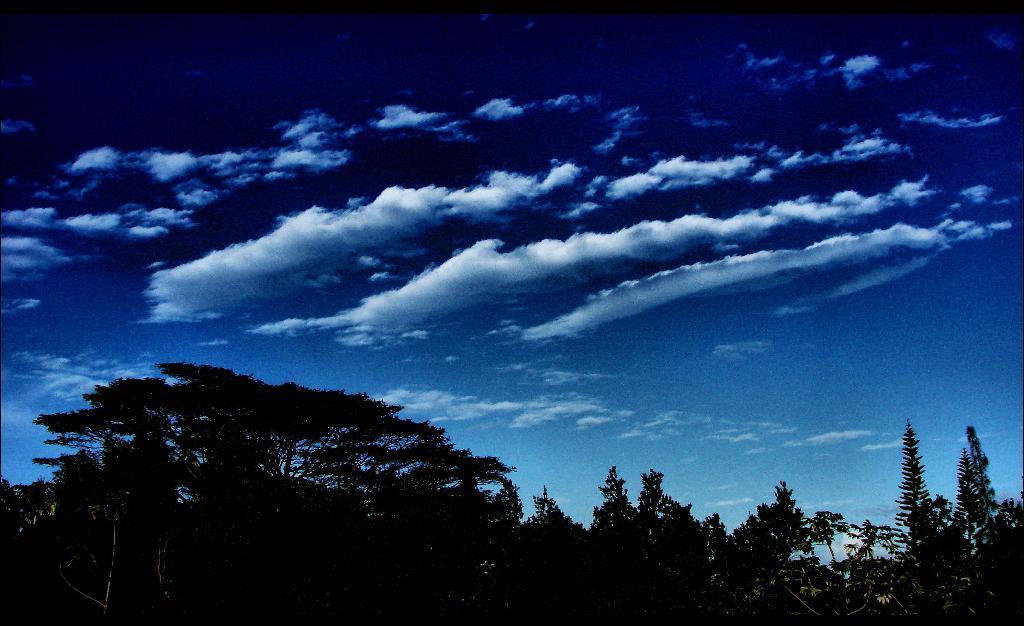Please provide a concise description of this image. In this image at the bottom there are some trees, and at the top of the image there is sky. 